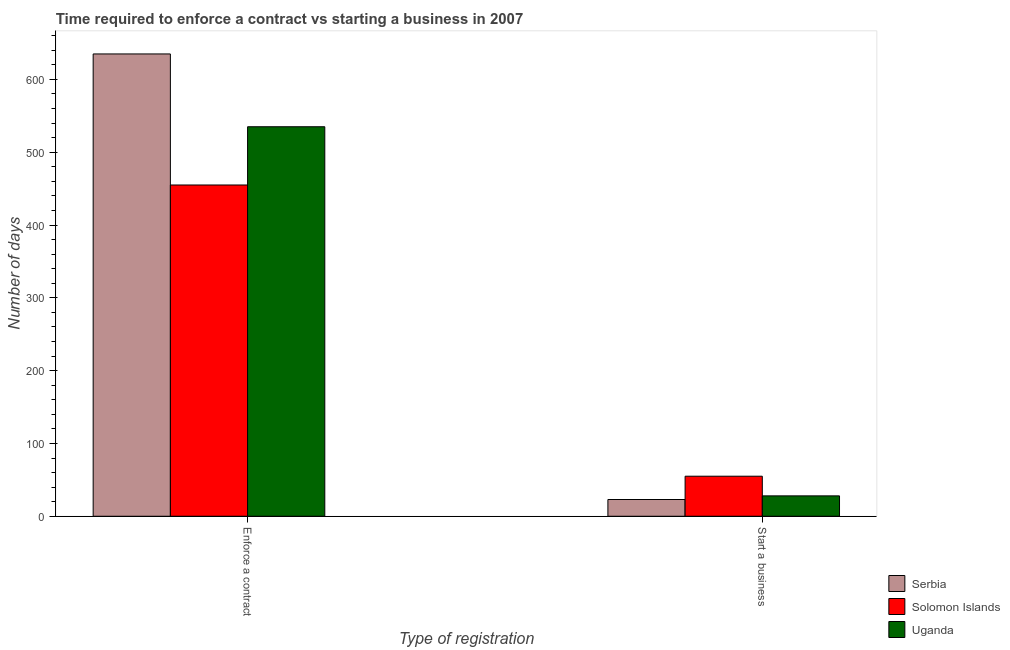How many bars are there on the 1st tick from the right?
Offer a very short reply. 3. What is the label of the 1st group of bars from the left?
Provide a short and direct response. Enforce a contract. What is the number of days to enforece a contract in Solomon Islands?
Your answer should be compact. 455. Across all countries, what is the maximum number of days to start a business?
Your response must be concise. 55. Across all countries, what is the minimum number of days to enforece a contract?
Your answer should be very brief. 455. In which country was the number of days to enforece a contract maximum?
Give a very brief answer. Serbia. In which country was the number of days to enforece a contract minimum?
Your answer should be very brief. Solomon Islands. What is the total number of days to start a business in the graph?
Provide a succinct answer. 106. What is the difference between the number of days to start a business in Uganda and that in Solomon Islands?
Give a very brief answer. -27. What is the difference between the number of days to enforece a contract in Solomon Islands and the number of days to start a business in Serbia?
Your answer should be compact. 432. What is the average number of days to enforece a contract per country?
Give a very brief answer. 541.67. What is the difference between the number of days to start a business and number of days to enforece a contract in Serbia?
Your answer should be very brief. -612. In how many countries, is the number of days to enforece a contract greater than 400 days?
Your answer should be very brief. 3. What is the ratio of the number of days to enforece a contract in Serbia to that in Solomon Islands?
Give a very brief answer. 1.4. In how many countries, is the number of days to enforece a contract greater than the average number of days to enforece a contract taken over all countries?
Give a very brief answer. 1. What does the 2nd bar from the left in Start a business represents?
Ensure brevity in your answer.  Solomon Islands. What does the 3rd bar from the right in Enforce a contract represents?
Offer a very short reply. Serbia. Are all the bars in the graph horizontal?
Offer a very short reply. No. Are the values on the major ticks of Y-axis written in scientific E-notation?
Ensure brevity in your answer.  No. Does the graph contain grids?
Your answer should be compact. No. How many legend labels are there?
Your response must be concise. 3. How are the legend labels stacked?
Give a very brief answer. Vertical. What is the title of the graph?
Offer a very short reply. Time required to enforce a contract vs starting a business in 2007. Does "Pacific island small states" appear as one of the legend labels in the graph?
Offer a very short reply. No. What is the label or title of the X-axis?
Offer a very short reply. Type of registration. What is the label or title of the Y-axis?
Your answer should be compact. Number of days. What is the Number of days in Serbia in Enforce a contract?
Offer a terse response. 635. What is the Number of days of Solomon Islands in Enforce a contract?
Provide a succinct answer. 455. What is the Number of days in Uganda in Enforce a contract?
Your response must be concise. 535. What is the Number of days of Serbia in Start a business?
Make the answer very short. 23. Across all Type of registration, what is the maximum Number of days of Serbia?
Offer a very short reply. 635. Across all Type of registration, what is the maximum Number of days of Solomon Islands?
Your response must be concise. 455. Across all Type of registration, what is the maximum Number of days in Uganda?
Your response must be concise. 535. What is the total Number of days in Serbia in the graph?
Offer a very short reply. 658. What is the total Number of days in Solomon Islands in the graph?
Provide a succinct answer. 510. What is the total Number of days in Uganda in the graph?
Keep it short and to the point. 563. What is the difference between the Number of days in Serbia in Enforce a contract and that in Start a business?
Offer a very short reply. 612. What is the difference between the Number of days in Solomon Islands in Enforce a contract and that in Start a business?
Your answer should be very brief. 400. What is the difference between the Number of days in Uganda in Enforce a contract and that in Start a business?
Give a very brief answer. 507. What is the difference between the Number of days in Serbia in Enforce a contract and the Number of days in Solomon Islands in Start a business?
Keep it short and to the point. 580. What is the difference between the Number of days of Serbia in Enforce a contract and the Number of days of Uganda in Start a business?
Keep it short and to the point. 607. What is the difference between the Number of days in Solomon Islands in Enforce a contract and the Number of days in Uganda in Start a business?
Offer a terse response. 427. What is the average Number of days of Serbia per Type of registration?
Make the answer very short. 329. What is the average Number of days of Solomon Islands per Type of registration?
Provide a short and direct response. 255. What is the average Number of days of Uganda per Type of registration?
Offer a very short reply. 281.5. What is the difference between the Number of days in Serbia and Number of days in Solomon Islands in Enforce a contract?
Provide a short and direct response. 180. What is the difference between the Number of days of Serbia and Number of days of Uganda in Enforce a contract?
Offer a very short reply. 100. What is the difference between the Number of days of Solomon Islands and Number of days of Uganda in Enforce a contract?
Keep it short and to the point. -80. What is the difference between the Number of days of Serbia and Number of days of Solomon Islands in Start a business?
Offer a very short reply. -32. What is the difference between the Number of days of Solomon Islands and Number of days of Uganda in Start a business?
Keep it short and to the point. 27. What is the ratio of the Number of days in Serbia in Enforce a contract to that in Start a business?
Offer a terse response. 27.61. What is the ratio of the Number of days in Solomon Islands in Enforce a contract to that in Start a business?
Make the answer very short. 8.27. What is the ratio of the Number of days of Uganda in Enforce a contract to that in Start a business?
Offer a terse response. 19.11. What is the difference between the highest and the second highest Number of days of Serbia?
Provide a succinct answer. 612. What is the difference between the highest and the second highest Number of days in Uganda?
Your response must be concise. 507. What is the difference between the highest and the lowest Number of days of Serbia?
Your response must be concise. 612. What is the difference between the highest and the lowest Number of days in Uganda?
Offer a very short reply. 507. 